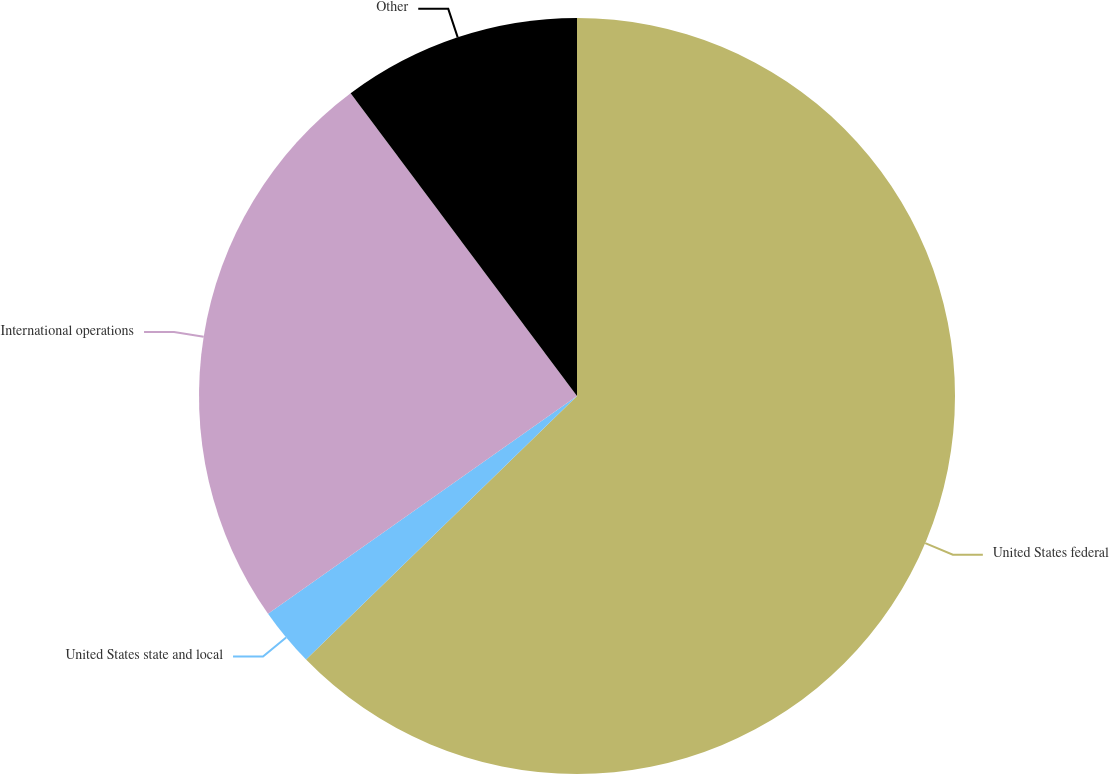Convert chart to OTSL. <chart><loc_0><loc_0><loc_500><loc_500><pie_chart><fcel>United States federal<fcel>United States state and local<fcel>International operations<fcel>Other<nl><fcel>62.72%<fcel>2.51%<fcel>24.55%<fcel>10.22%<nl></chart> 